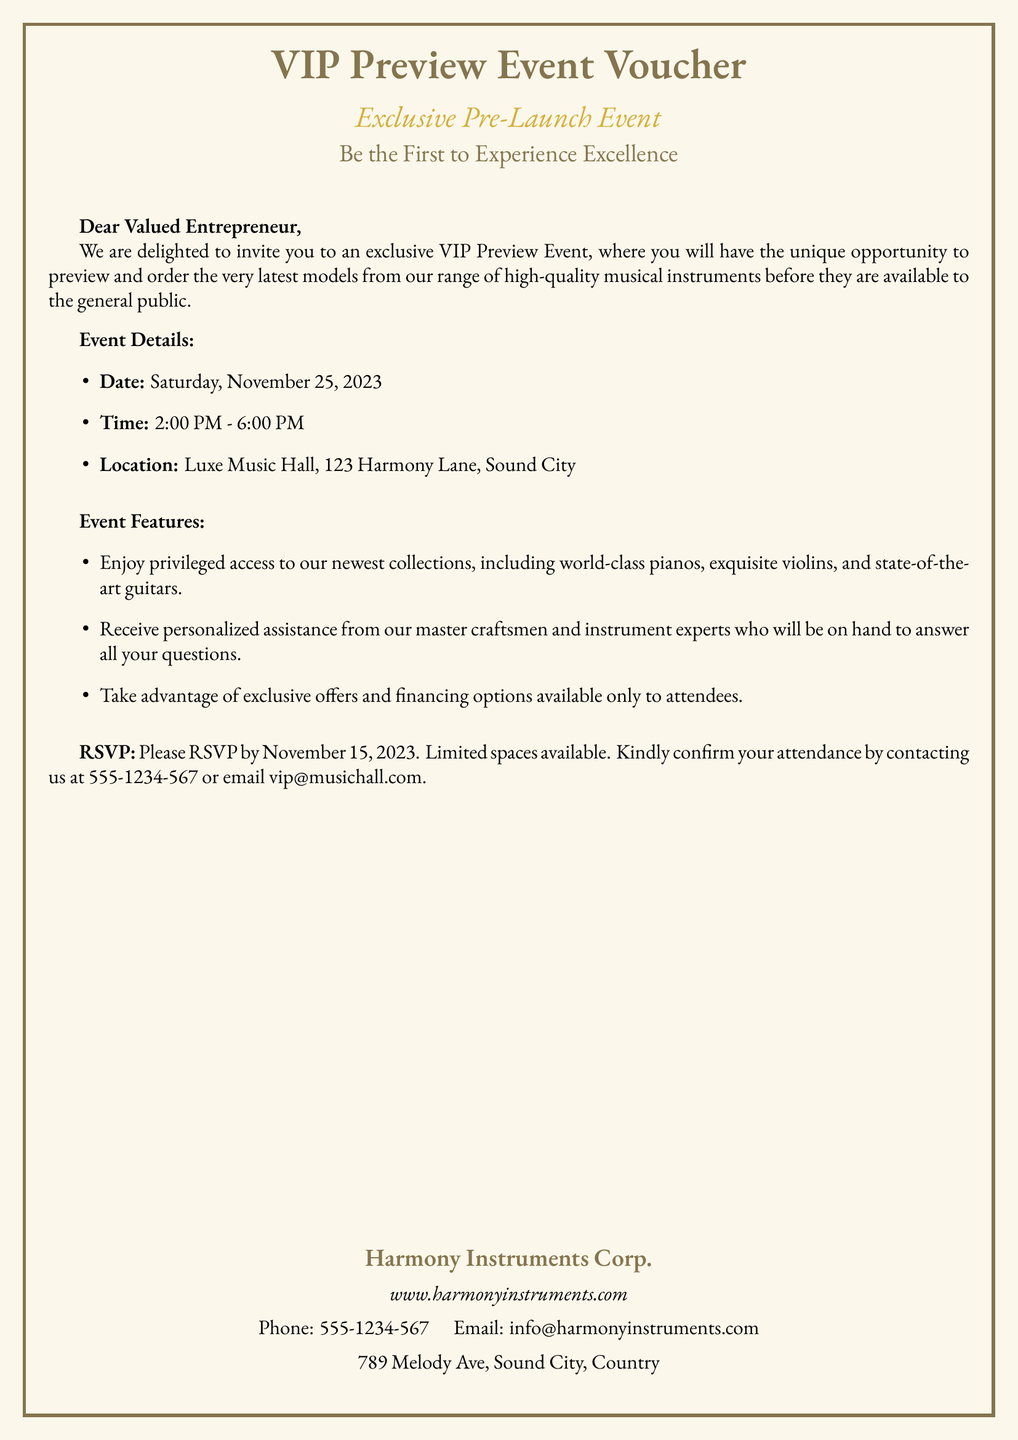What is the date of the VIP Preview Event? The date is explicitly mentioned in the event details section of the document.
Answer: Saturday, November 25, 2023 What time does the event start? The starting time is indicated clearly in the event details.
Answer: 2:00 PM Where is the event located? The location is provided in the event details section for attendees.
Answer: Luxe Music Hall, 123 Harmony Lane, Sound City What types of musical instruments will be previewed? The document lists several types of instruments that will be available during the event.
Answer: pianos, violins, guitars When is the RSVP deadline? The RSVP deadline is specified within the text, indicating the last date to confirm attendance.
Answer: November 15, 2023 What should attendees contact for RSVP? The document provides contact methods for confirming attendance.
Answer: 555-1234-567 or email vip@musichall.com What company is hosting the event? The hosting company is mentioned at the bottom of the document.
Answer: Harmony Instruments Corp What type of offers are available at the event? The document indicates that special offers will be exclusive to attendees.
Answer: exclusive offers and financing options What is the end time for the event? The end time is included in the event details for clarity.
Answer: 6:00 PM 